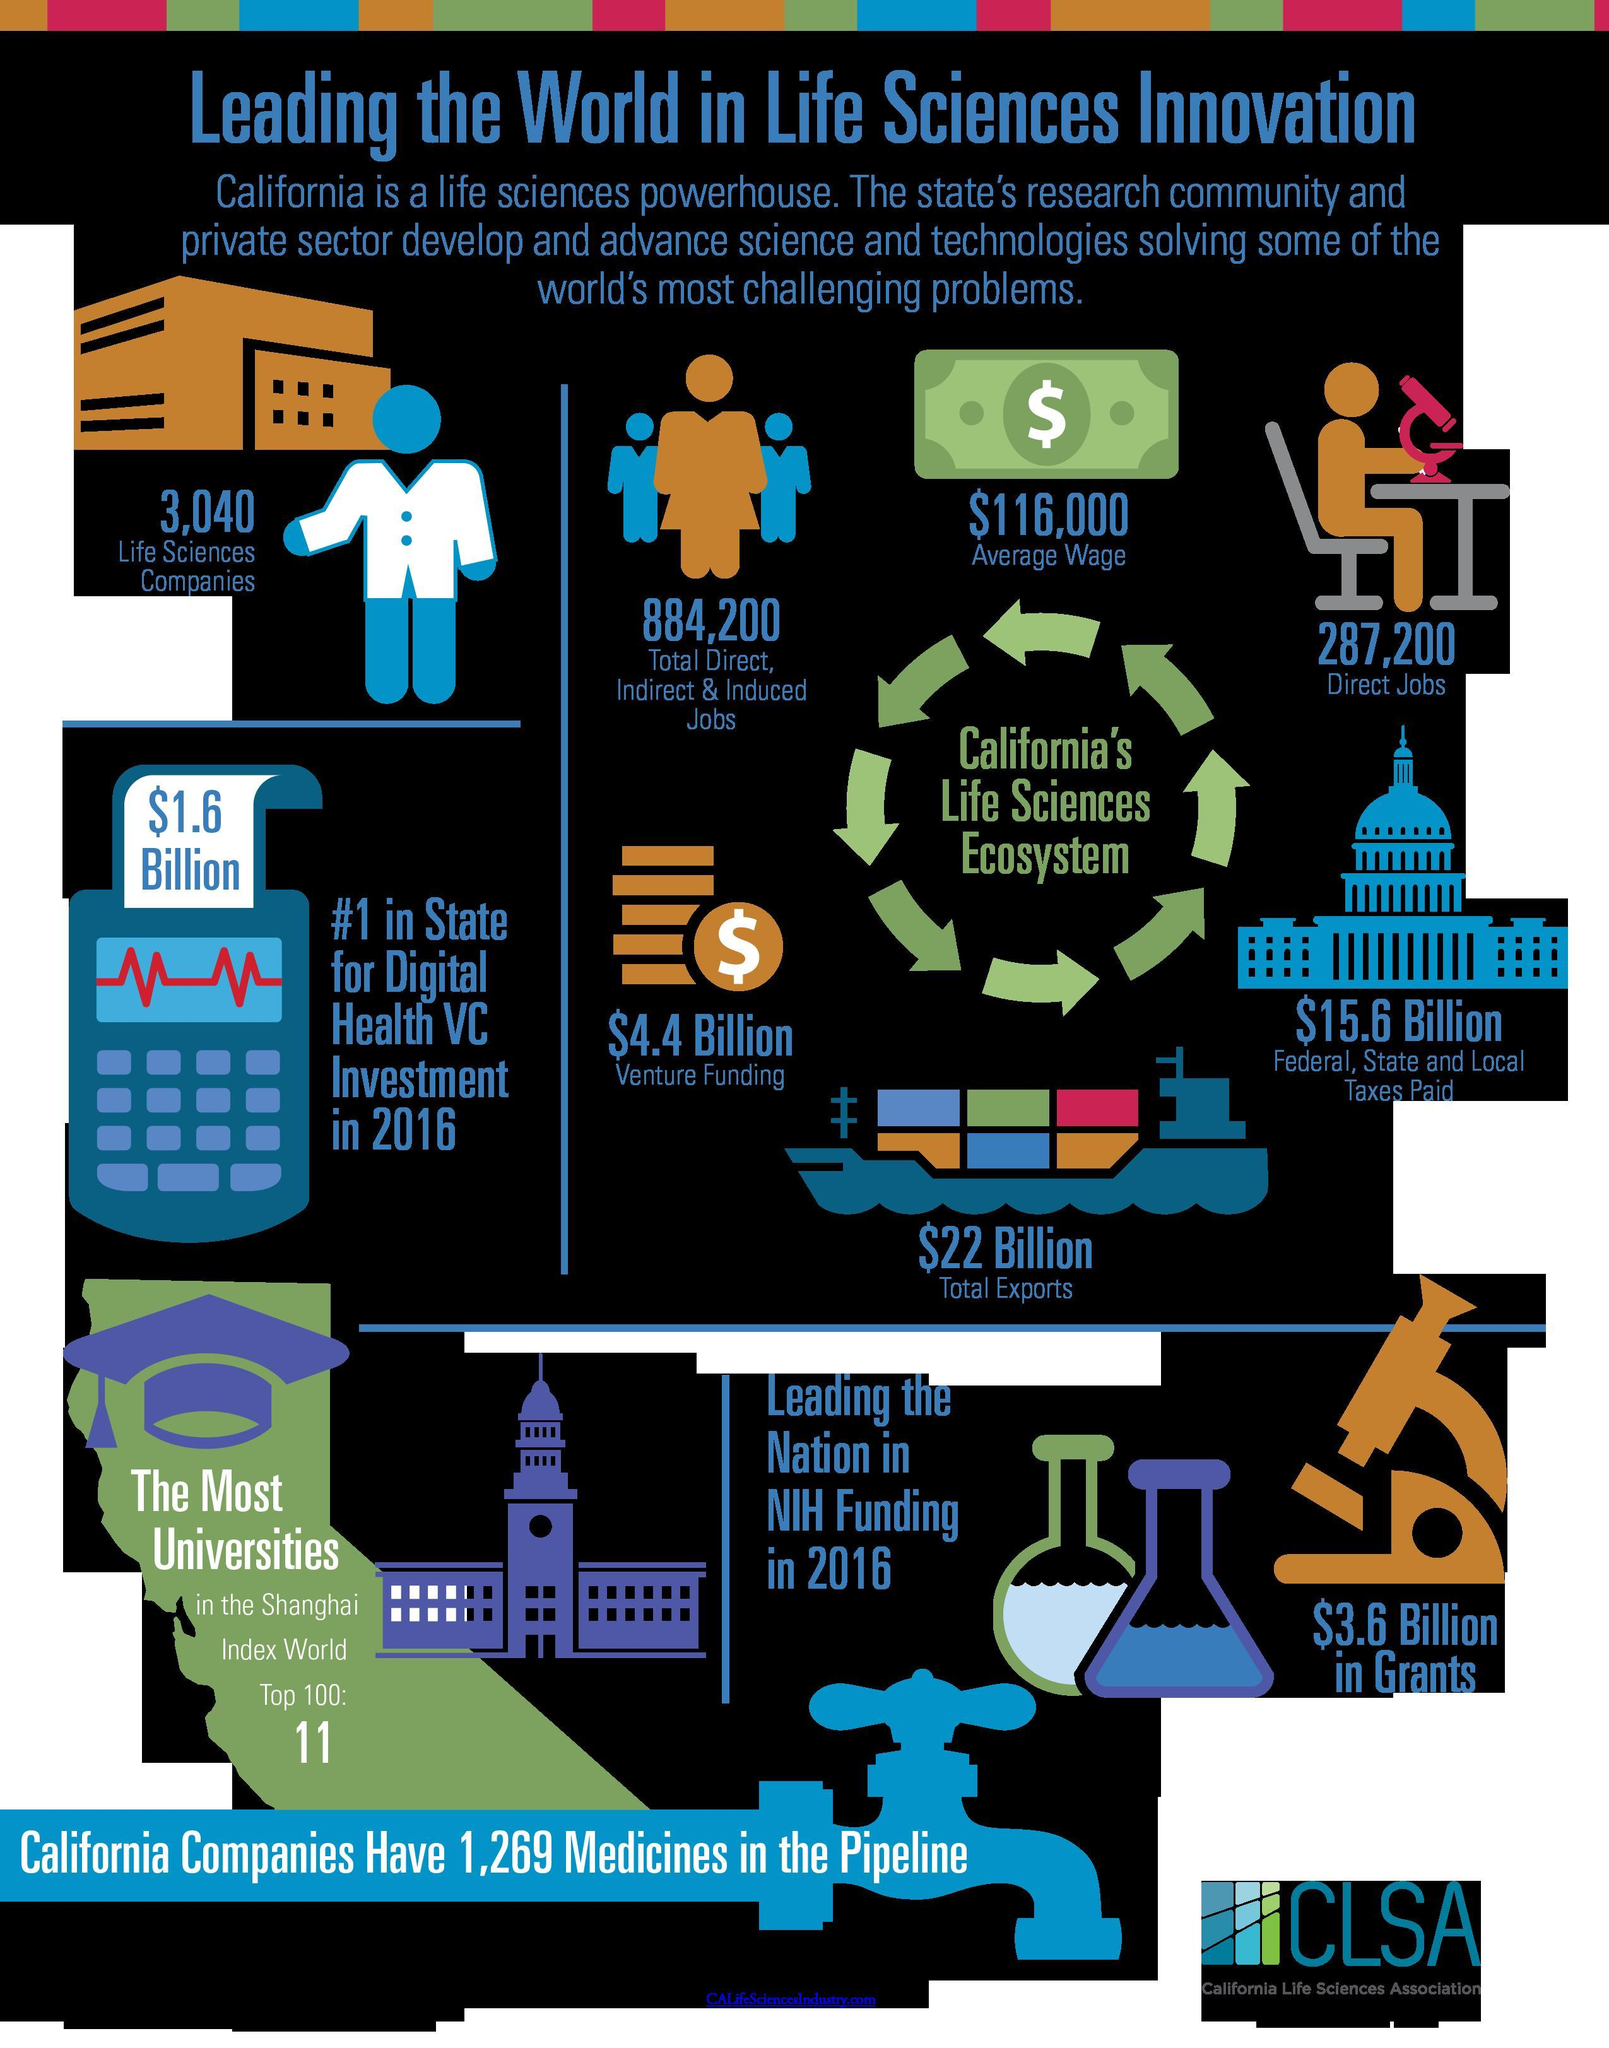How much was the digital health VC investment in 2016
Answer the question with a short phrase. $1.6 Billion How many direct jobs do California's Life Sciences Ecosystem have 287,200 What is the average wage in the life sciences industry $116,000 How many Life Sciences companies in california 3,040 11 of California's university have found place where Shanghai Index World Top 100 What funding does the microscope indicate 43.6 billion in grants 